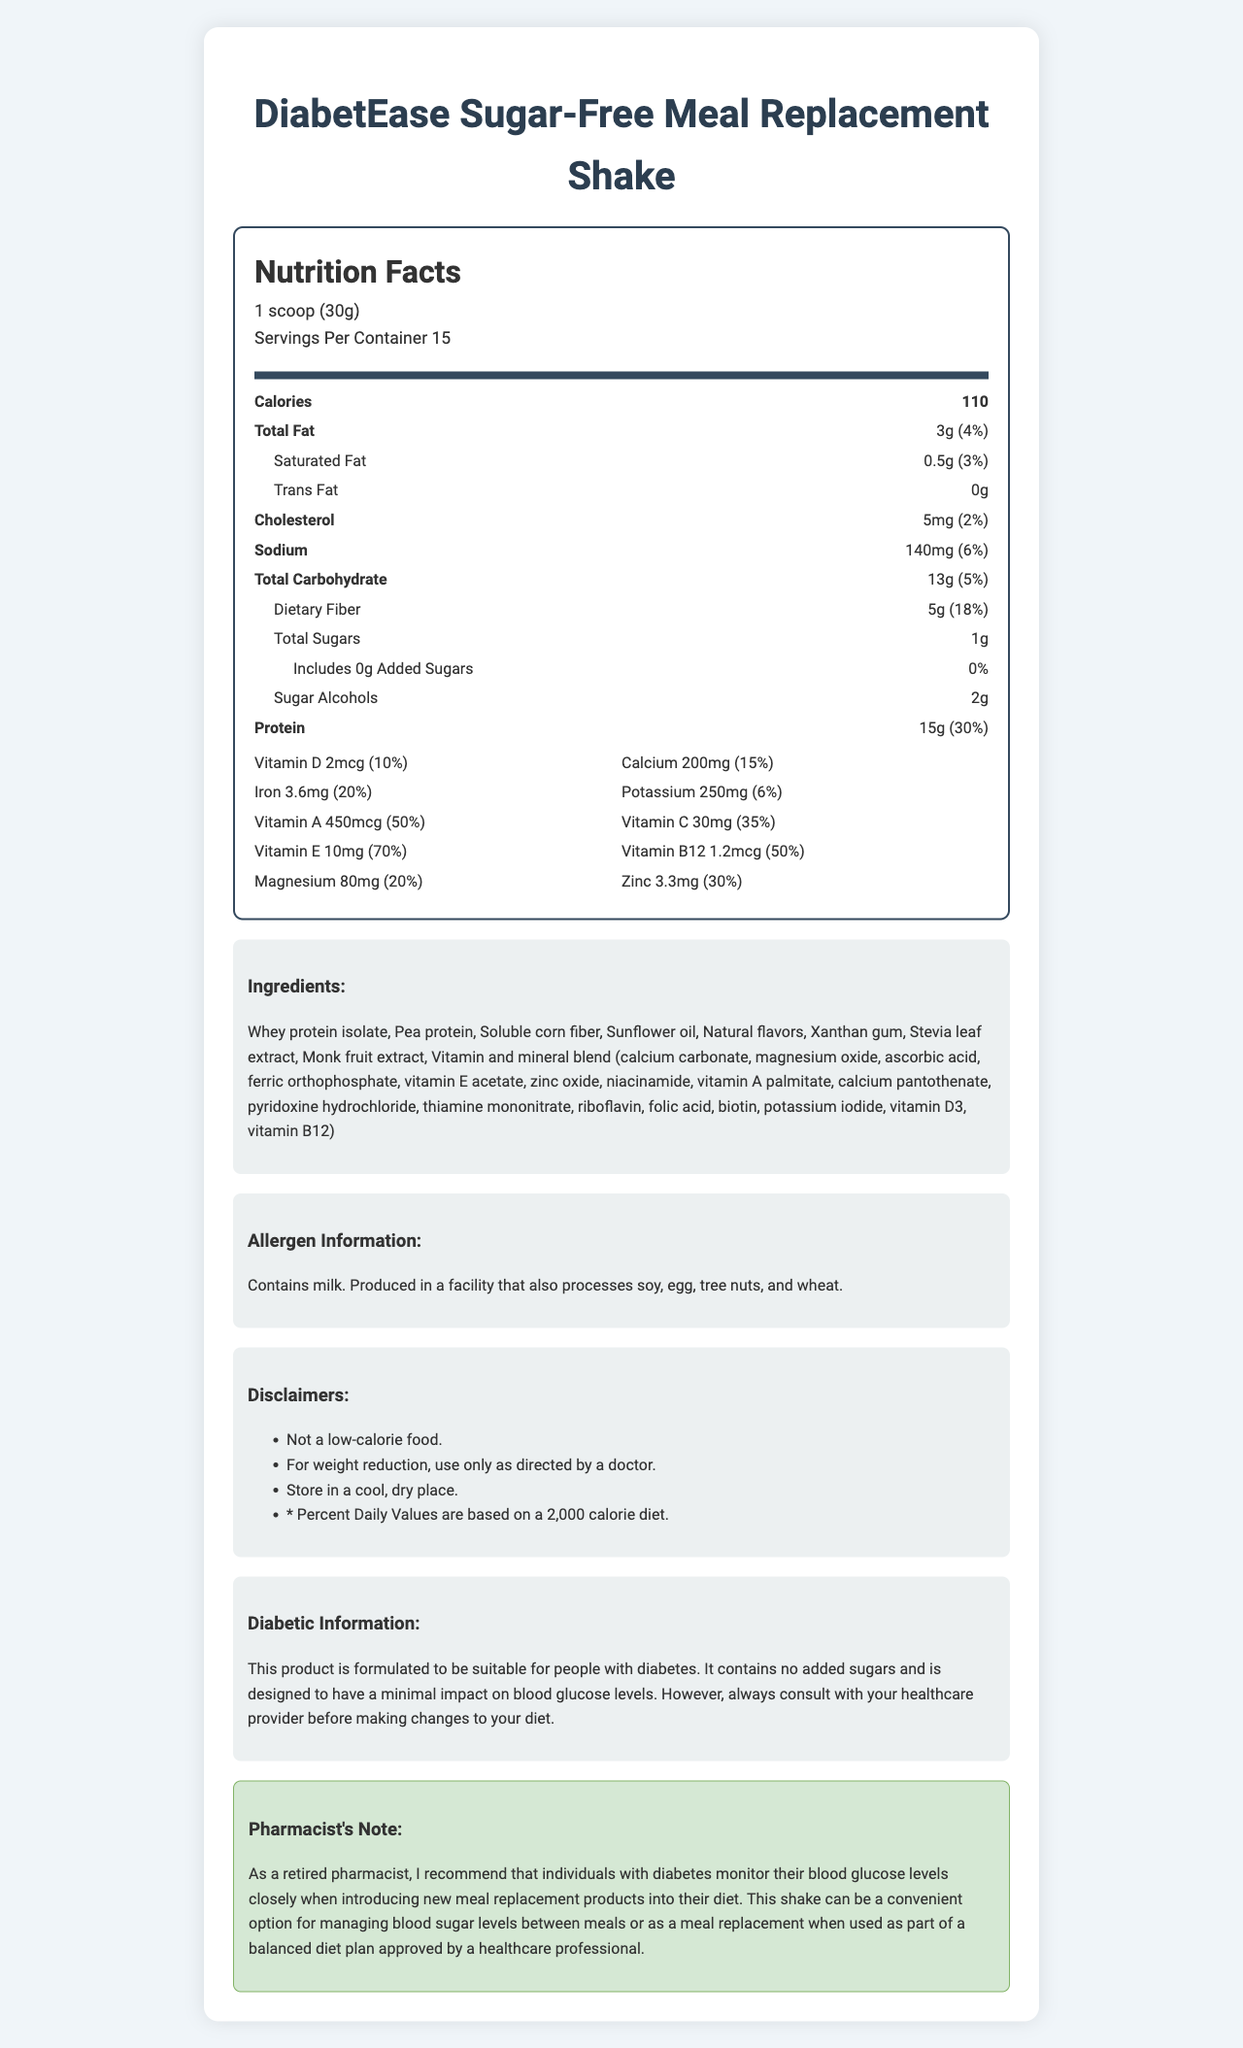what is the serving size for the DiabetEase Sugar-Free Meal Replacement Shake? The serving size is listed as "1 scoop (30g)" in the document.
Answer: 1 scoop (30g) How many calories are there per serving? The document states that there are 110 calories per serving.
Answer: 110 What is the total fat content per serving? The total fat content per serving is "3g," which is "4%" of the daily value.
Answer: 3g (4%) What is the amount of dietary fiber and its daily value percentage in this product? The dietary fiber amount is listed as "5g," which is "18%" of the daily value.
Answer: 5g (18%) Does this product contain any added sugars? The document indicates that the product contains "0g Added Sugars," which is "0%" of the daily value.
Answer: No What is the protein content per serving, both in grams and daily value percentage? The protein content per serving is "15g," which corresponds to "30%" of the daily value.
Answer: 15g (30%) Which of the following vitamins has the highest daily value percentage? A. Vitamin D B. Vitamin C C. Vitamin E Vitamin E has a daily value percentage of "70%," which is higher than Vitamin D (10%) and Vitamin C (35%).
Answer: C. Vitamin E Which of the following allergens may be present in this product? A. Soy B. Peanuts C. Shellfish The document states that the product is produced in a facility that also processes soy.
Answer: A. Soy Can this shake be used as part of a weight reduction plan? One of the disclaimers mentions that for weight reduction, the shake should be used only as directed by a doctor.
Answer: Yes Is this product specifically formulated to be suitable for people with diabetes? The diabetic information section states that the product is formulated to be suitable for people with diabetes.
Answer: Yes Does this product contain any trans fat? The document lists "Trans Fat 0g," indicating the product has no trans fat.
Answer: No What are the main ingredients in this meal replacement shake? The ingredients are specified in the ingredients section of the document.
Answer: Whey protein isolate, Pea protein, Soluble corn fiber, Sunflower oil, Natural flavors, Xanthan gum, Stevia leaf extract, Monk fruit extract, Vitamin and mineral blend What is the total amount of potassium in one serving, and its daily value percentage? The serving contains "250mg" of potassium, which is "6%" of the daily value.
Answer: 250mg (6%) Summarize the main points of the document. The answer encompasses the key nutrition facts, special dietary information, ingredient list, and allergen details from the document.
Answer: The document provides detailed nutrition information for the DiabetEase Sugar-Free Meal Replacement Shake. One serving size is 1 scoop (30g), and each container provides 15 servings. The shake has 110 calories per serving and contains 3g of total fat, 13g of carbohydrates, 5g of dietary fiber, and 15g of protein. Important vitamins and minerals include Vitamin E (70% DV), Vitamin A (50% DV), and Vitamin C (35% DV). It contains no added sugars and is designed for people with diabetes. Allergen information states it contains milk and is produced in a facility that processes soy, egg, tree nuts, and wheat. Is the specific percentage of daily value provided for Vitamin D? The daily value percentage for Vitamin D is listed as "10%" in the document.
Answer: Yes How much magnesium does one serving of this product contain? The magnesium content per serving is "80mg," which constitutes "20%" of the daily value.
Answer: 80mg (20%) Can you find information about the expiration date of this product in the document? The document does not provide any details regarding the expiration date of the product.
Answer: Not enough information 